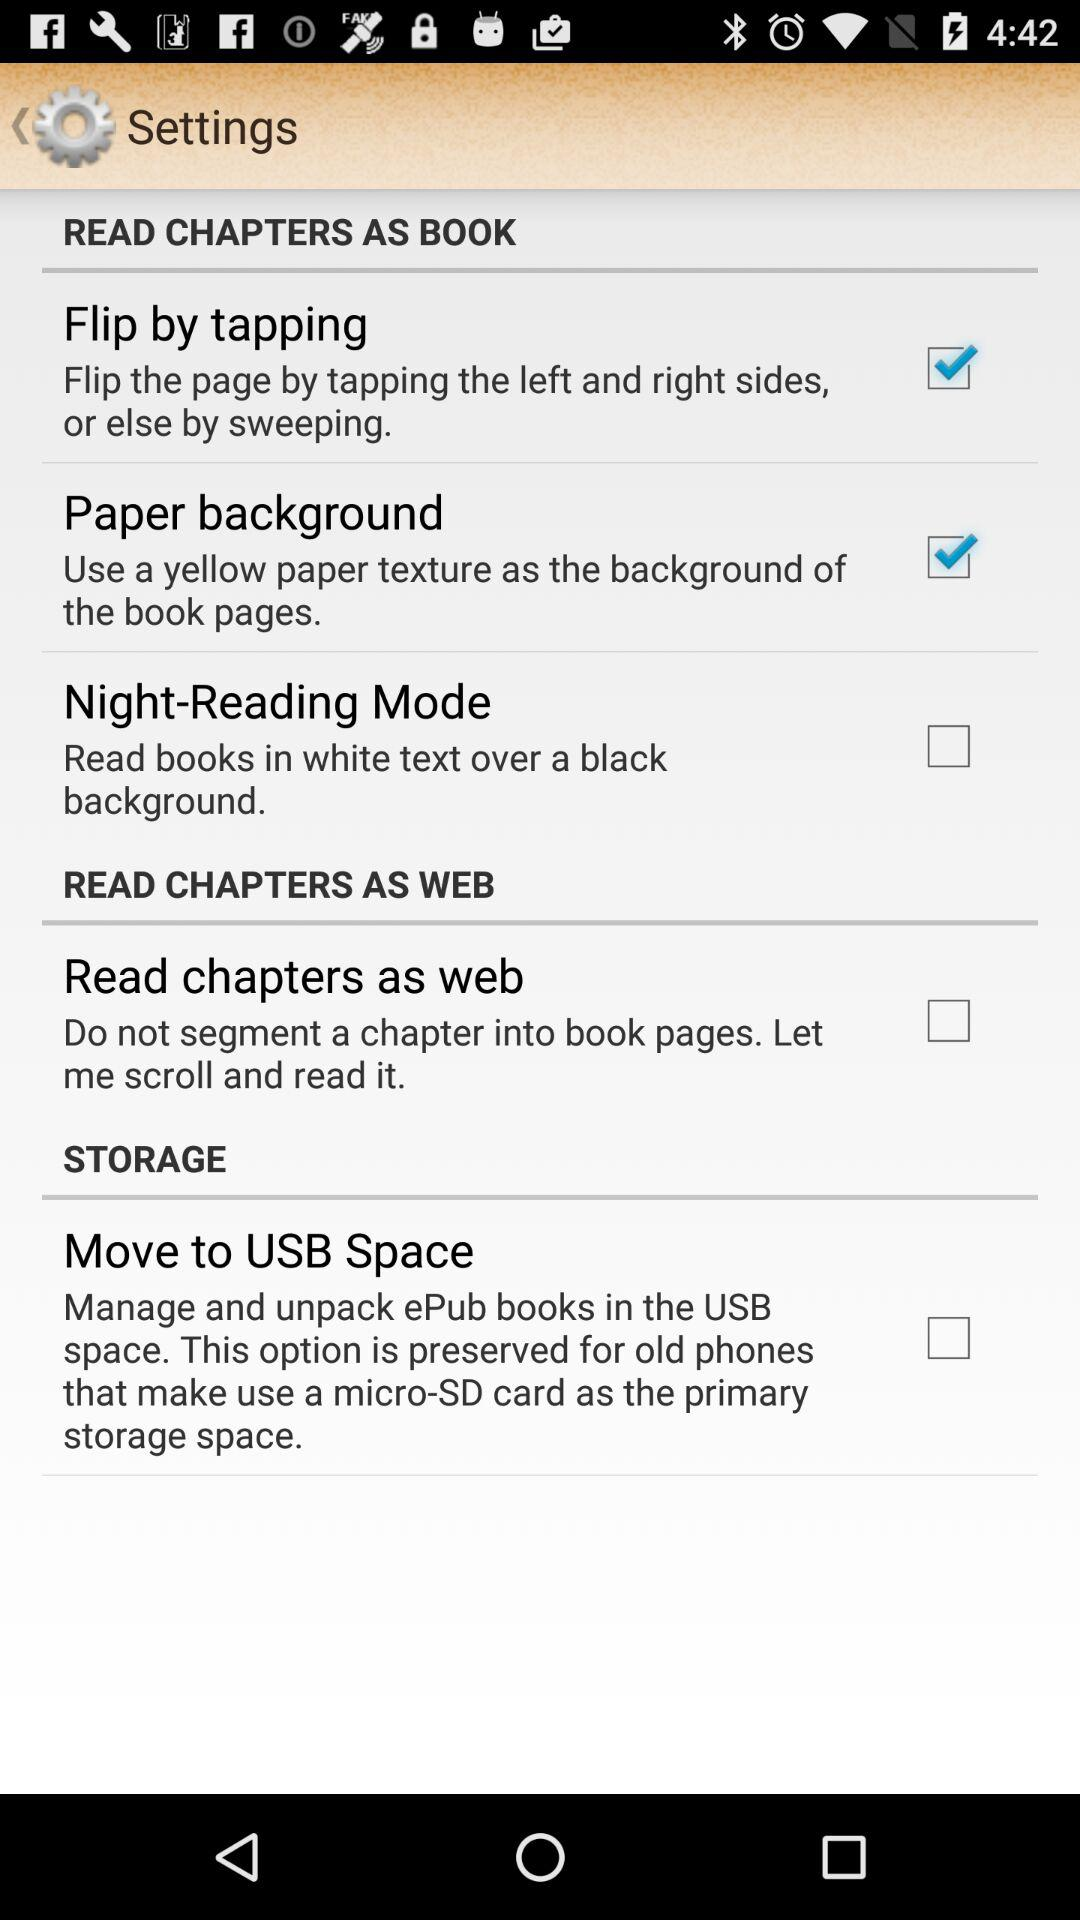What is the status of the Night-Reading Mode? The status of the Night-Reading Mode is unchecked. 